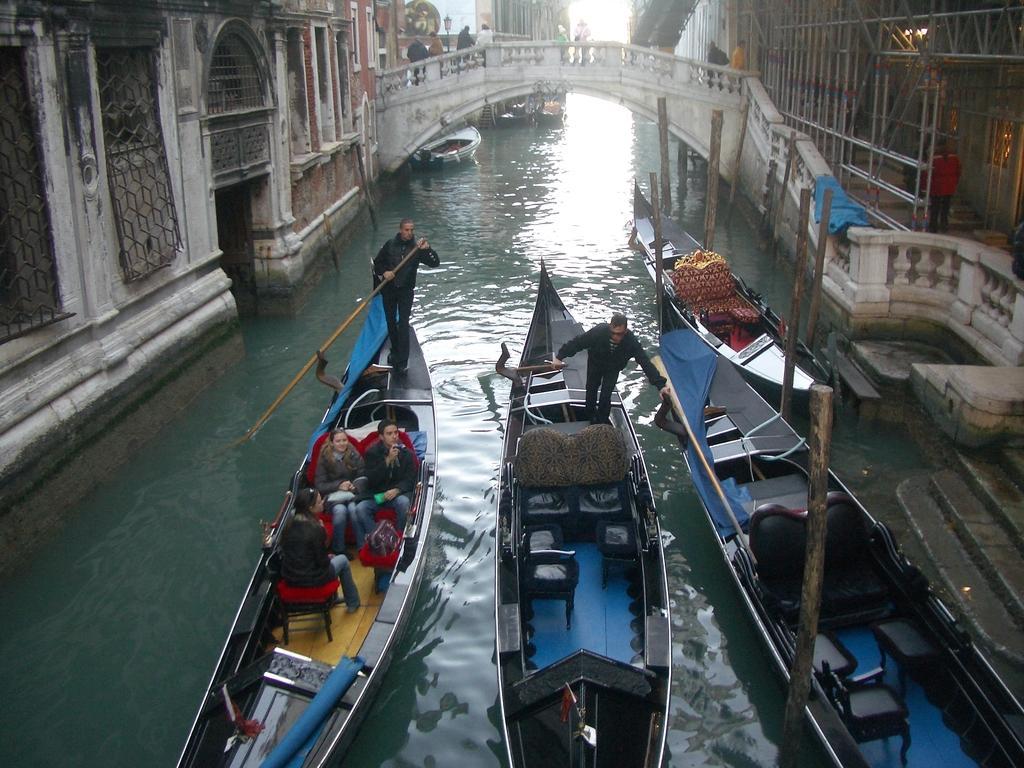In one or two sentences, can you explain what this image depicts? In this image, we can see people are sailing boats on the water. Here we can see few boats are above the water. On the right side of the image, we can see stairs and wooden poles. Top of the image, we can see grille, railings, bridge, people, lights and sky. 